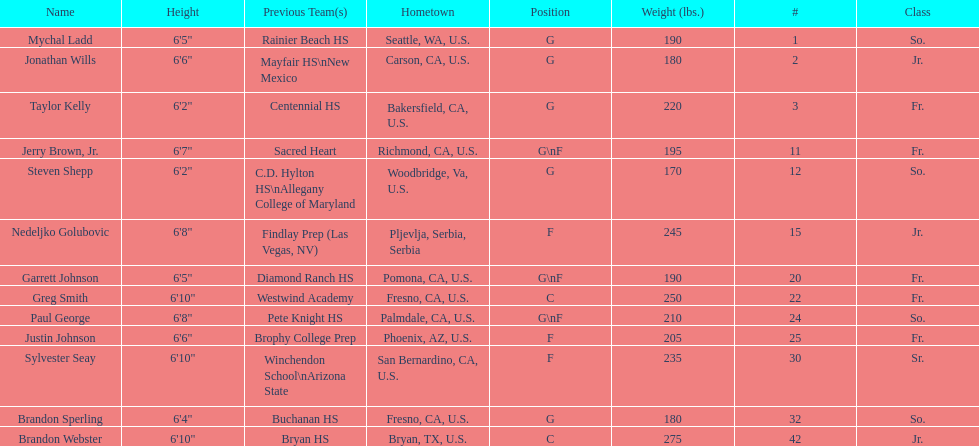Which player who is only a forward (f) is the shortest? Justin Johnson. 